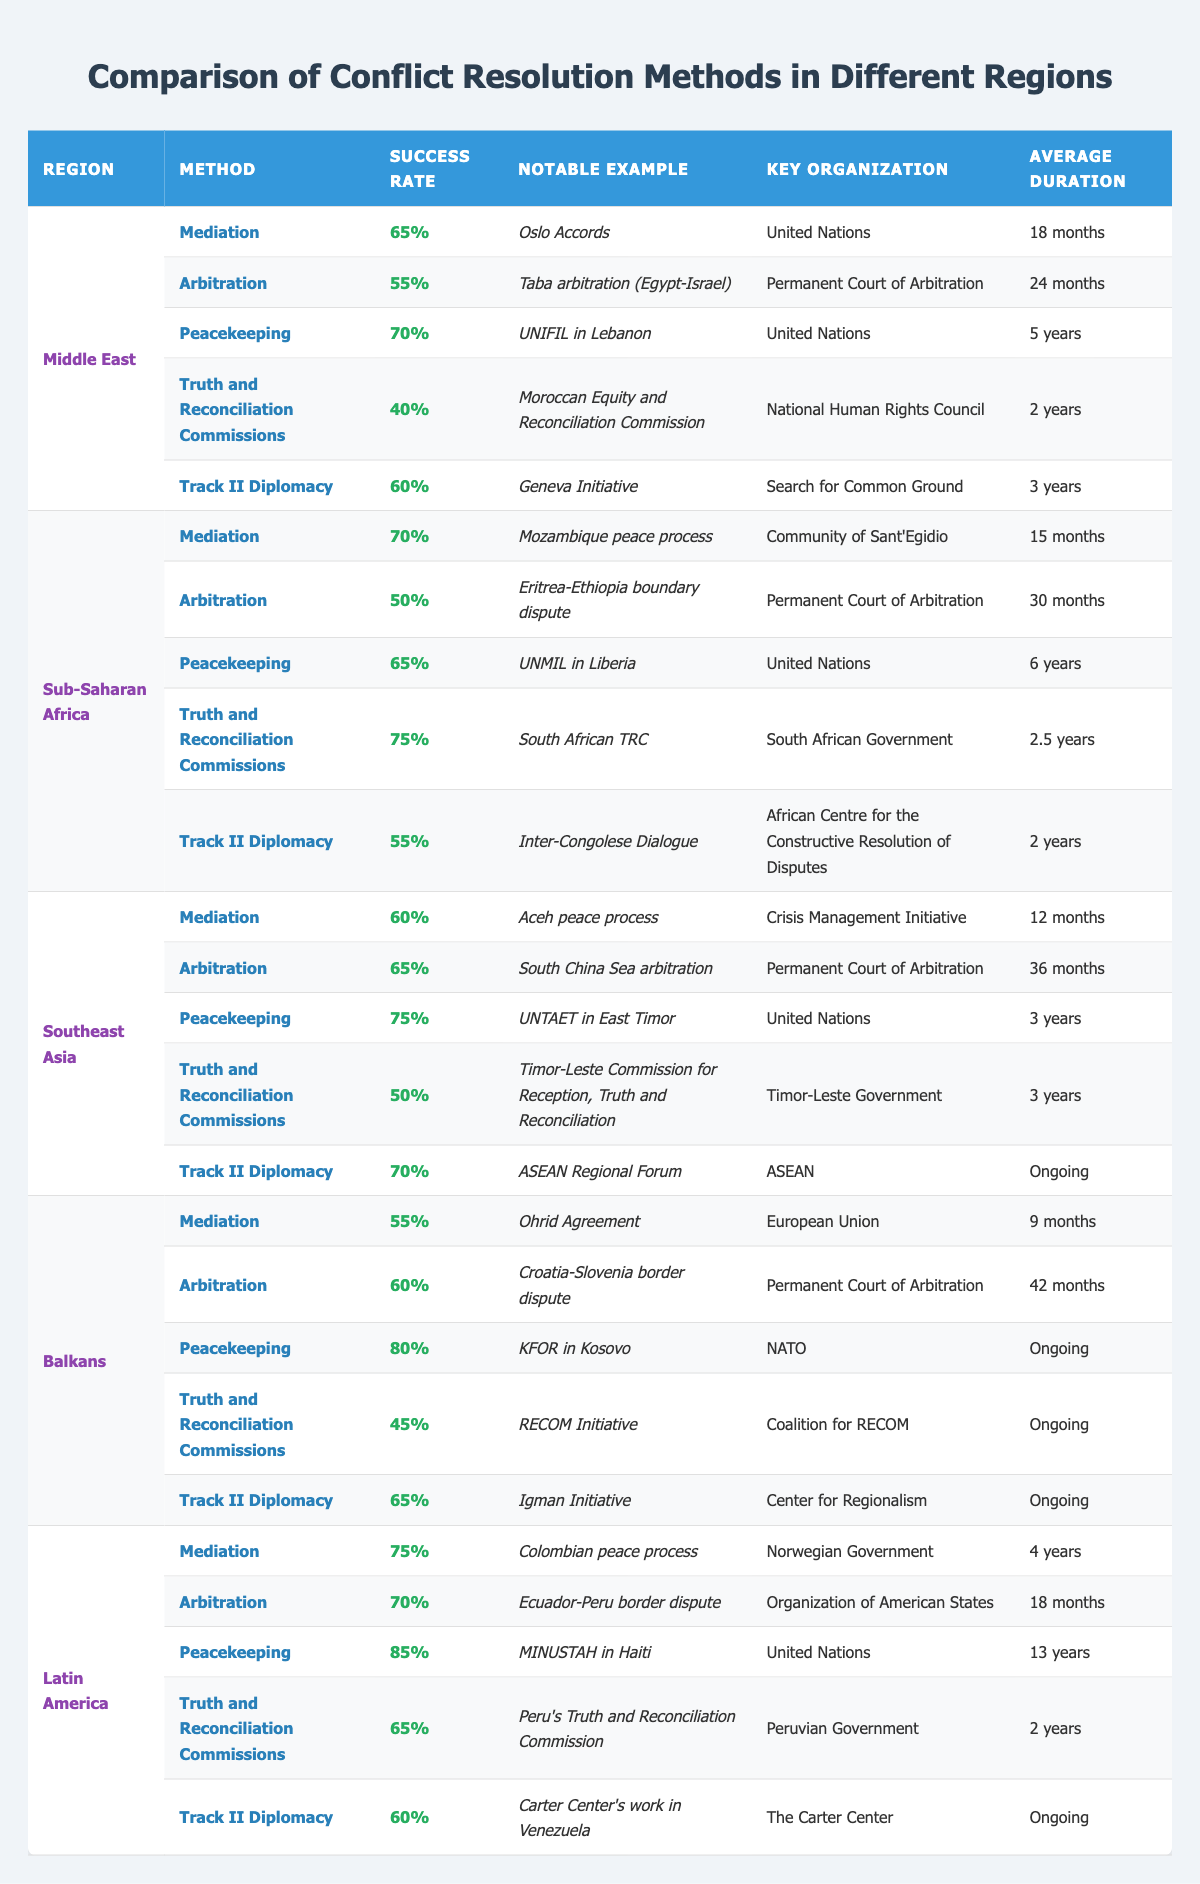What is the success rate of Truth and Reconciliation Commissions in Sub-Saharan Africa? The table shows that in Sub-Saharan Africa, the success rate for Truth and Reconciliation Commissions is 75%.
Answer: 75% Which region has the highest success rate for Peacekeeping? The table indicates that Latin America has the highest success rate for Peacekeeping at 85%.
Answer: 85% What is the average success rate of Mediation across all regions? The success rates for Mediation are 65%, 70%, 60%, 55%, and 75% for the respective regions. Summing these gives 65 + 70 + 60 + 55 + 75 = 325. To find the average, we divide by the number of regions (5), resulting in 325/5 = 65.
Answer: 65% Is there a region where Track II Diplomacy has a success rate of over 70%? Upon reviewing the table, Track II Diplomacy in Southeast Asia has a success rate of 70%, which is not over 70%. Thus, the answer is no.
Answer: No Which conflict resolution method in the Balkans has the lowest success rate, and what is that rate? Looking at the Balkans' data, the method with the lowest success rate is Truth and Reconciliation Commissions, with a success rate of 45%.
Answer: 45% 